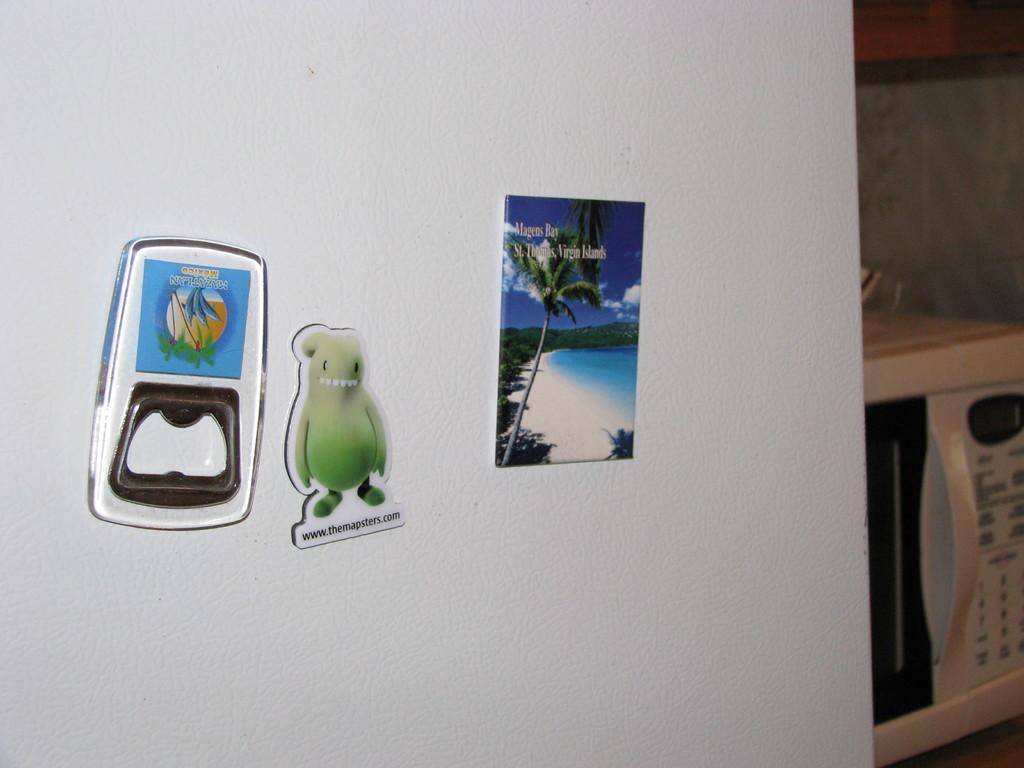In one or two sentences, can you explain what this image depicts? Here in this picture we can see stickers present over a place and beside that we can see a microwave Oven present on a table. 